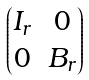Convert formula to latex. <formula><loc_0><loc_0><loc_500><loc_500>\begin{pmatrix} I _ { r } & 0 \\ 0 & B _ { r } \\ \end{pmatrix}</formula> 